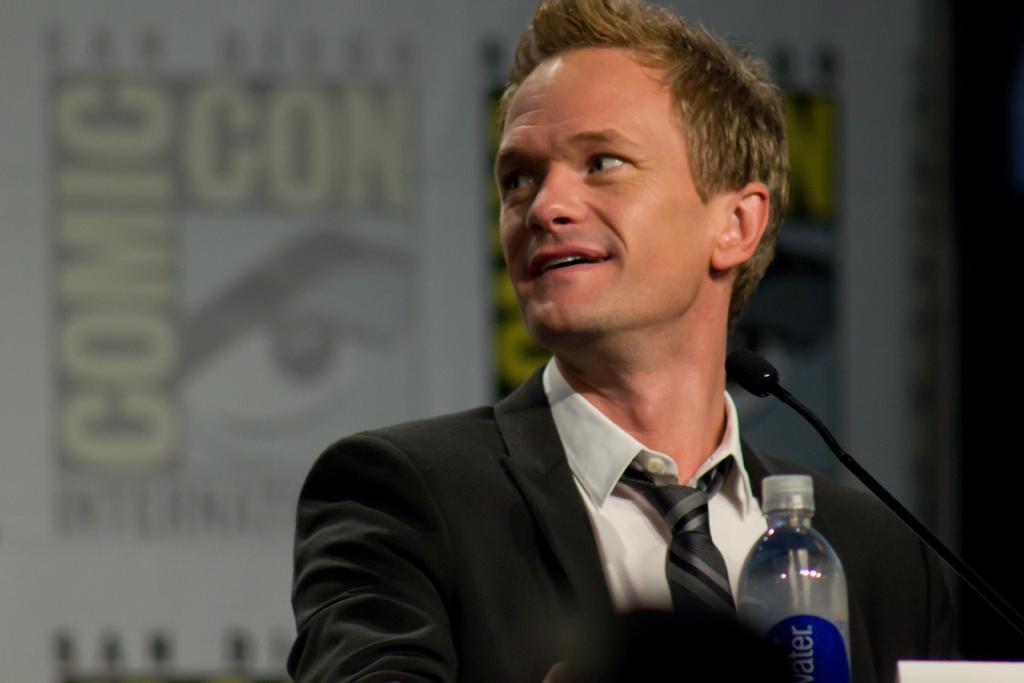How would you summarize this image in a sentence or two? This picture shows a man standing with a smile on his face and we see a microphone in front of him and a water bottle 